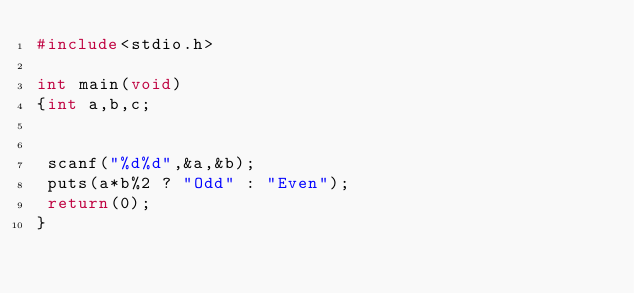Convert code to text. <code><loc_0><loc_0><loc_500><loc_500><_C_>#include<stdio.h>

int main(void)
{int a,b,c;
 
 
 scanf("%d%d",&a,&b);
 puts(a*b%2 ? "Odd" : "Even");
 return(0);
}</code> 